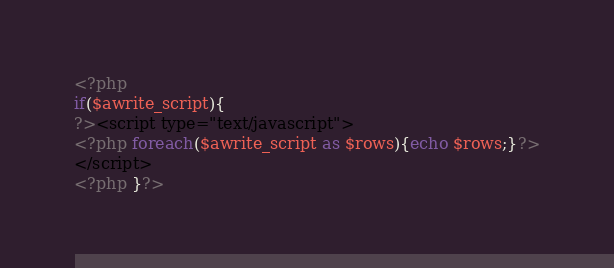Convert code to text. <code><loc_0><loc_0><loc_500><loc_500><_PHP_><?php
if($awrite_script){
?><script type="text/javascript">
<?php foreach($awrite_script as $rows){echo $rows;}?>
</script>
<?php }?></code> 